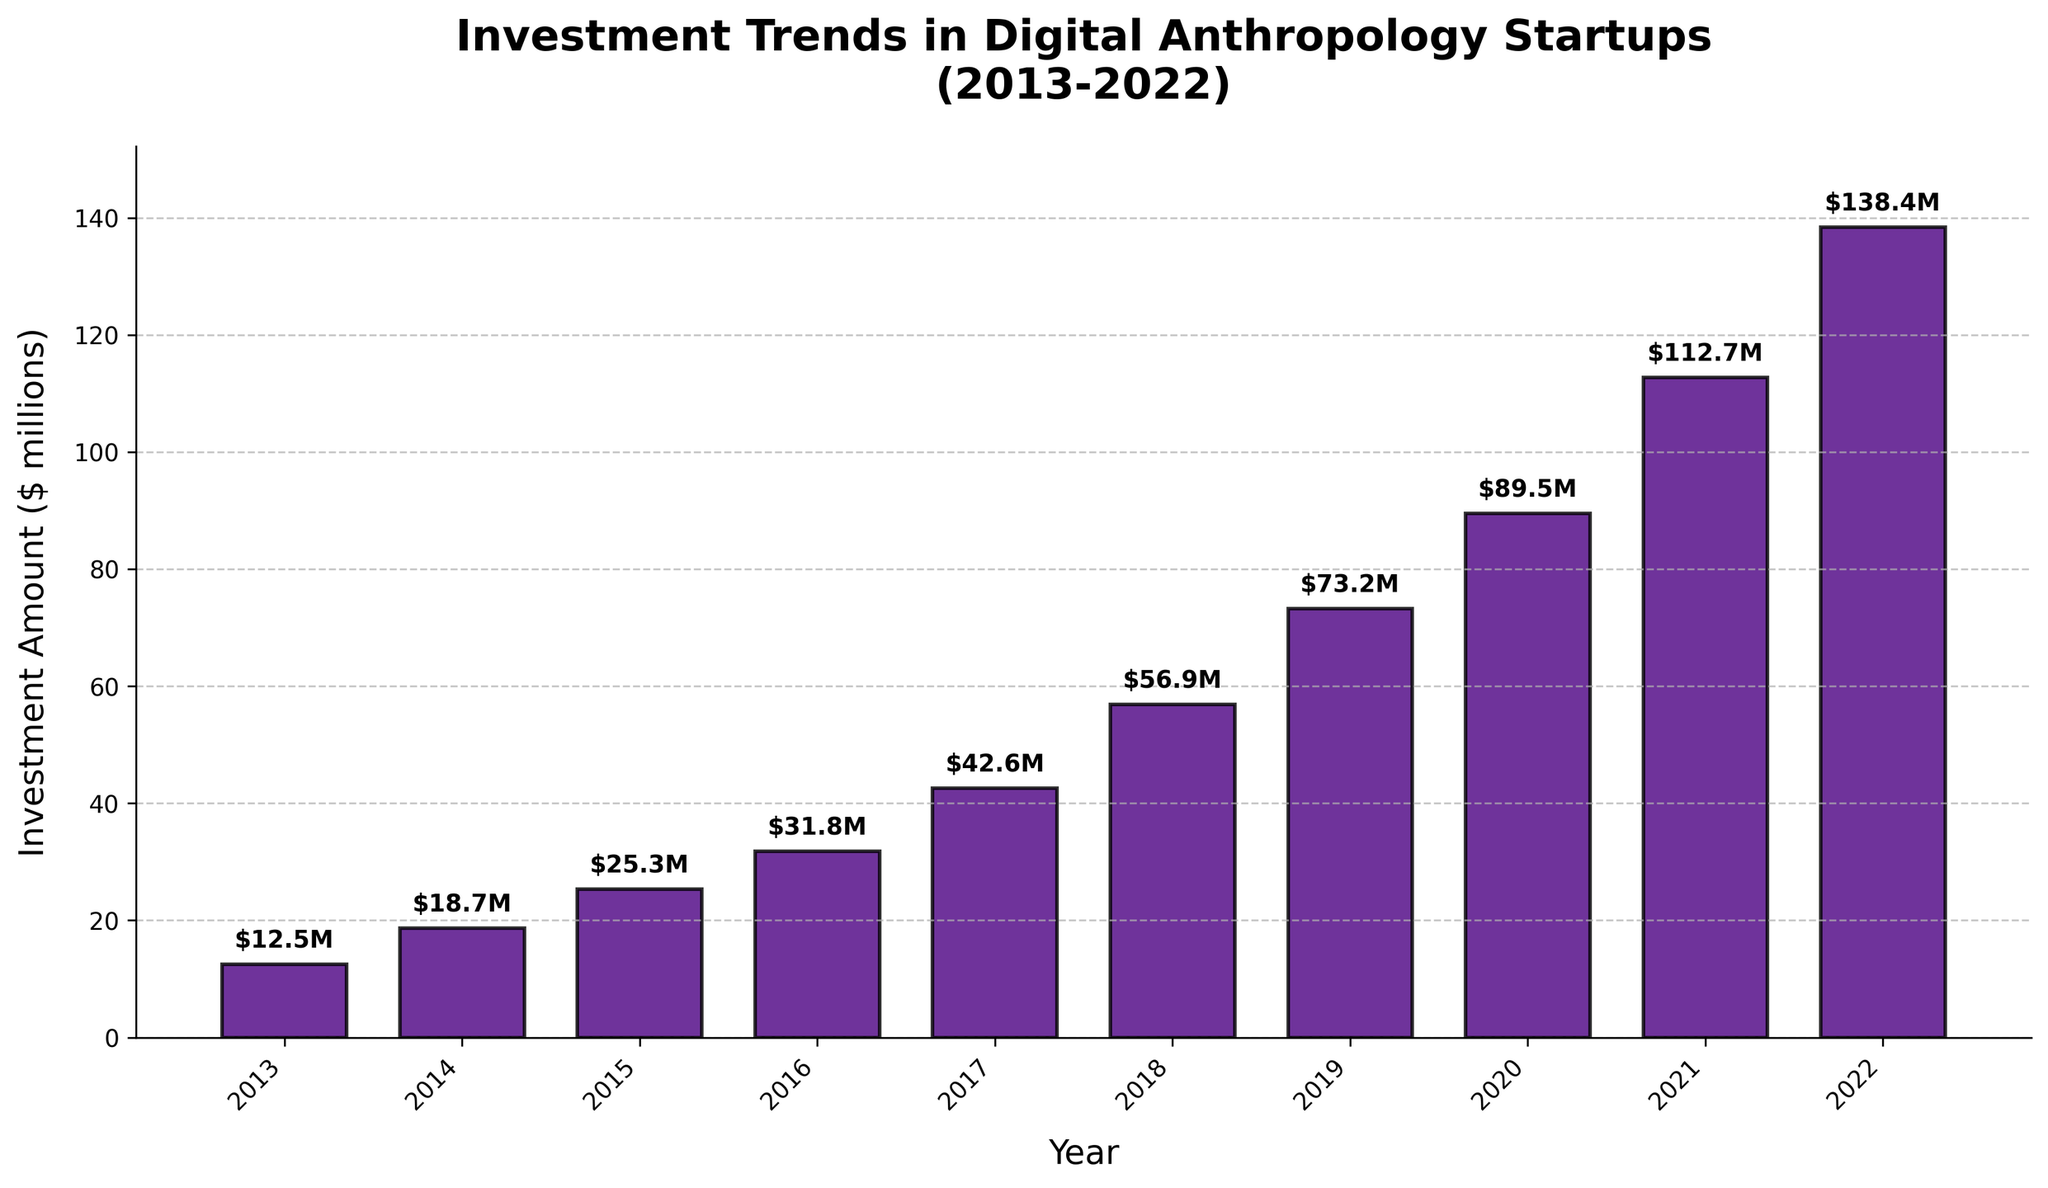What is the total investment amount from 2013 to 2022? To find the total investment amount from 2013 to 2022, sum the individual investments for each year: 12.5 + 18.7 + 25.3 + 31.8 + 42.6 + 56.9 + 73.2 + 89.5 + 112.7 + 138.4 = 601.6 million dollars.
Answer: 601.6 million dollars Which year had the highest investment amount? By comparing the height of the bars, the tallest bar corresponds to the year with the highest investment. Since 2022 has the highest bar, the highest investment amount was in 2022.
Answer: 2022 How much did the investment amount increase from 2013 to 2014? Subtract the investment amount in 2013 from the investment amount in 2014: 18.7 - 12.5 = 6.2 million dollars.
Answer: 6.2 million dollars What is the difference in investment amount between 2017 and 2020? Calculate the difference by subtracting the 2017 investment amount from the 2020 investment amount: 89.5 - 42.6 = 46.9 million dollars.
Answer: 46.9 million dollars Did the investment amount ever decrease compared to the previous year? By visually examining the trend in the bar heights, we can see that the investment amount consistently increased each year from 2013 to 2022.
Answer: No What is the average annual investment amount from 2013 to 2022? Calculate the average by adding the investment amounts for each year and then dividing by the number of years: (12.5 + 18.7 + 25.3 + 31.8 + 42.6 + 56.9 + 73.2 + 89.5 + 112.7 + 138.4) / 10 = 60.16 million dollars.
Answer: 60.16 million dollars By how much did the investment amount increase from 2018 to 2019? Subtract the investment amount in 2018 from the investment amount in 2019: 73.2 - 56.9 = 16.3 million dollars.
Answer: 16.3 million dollars What was the smallest investment amount between 2013 and 2022? The shortest bar on the chart corresponds to the smallest investment amount, which was in 2013 at 12.5 million dollars.
Answer: 12.5 million dollars How does the investment amount in 2016 compare to that in 2015? By comparing the heights of the bars for 2016 and 2015, we see that the investment amount in 2016 (31.8 million dollars) is greater than in 2015 (25.3 million dollars).
Answer: 2016 is greater than 2015 What is the difference in investment amount between the two highest investment years? Identify the two highest investments from the chart, which are 2022 (138.4 million dollars) and 2021 (112.7 million dollars). Subtract to find the difference: 138.4 - 112.7 = 25.7 million dollars.
Answer: 25.7 million dollars 